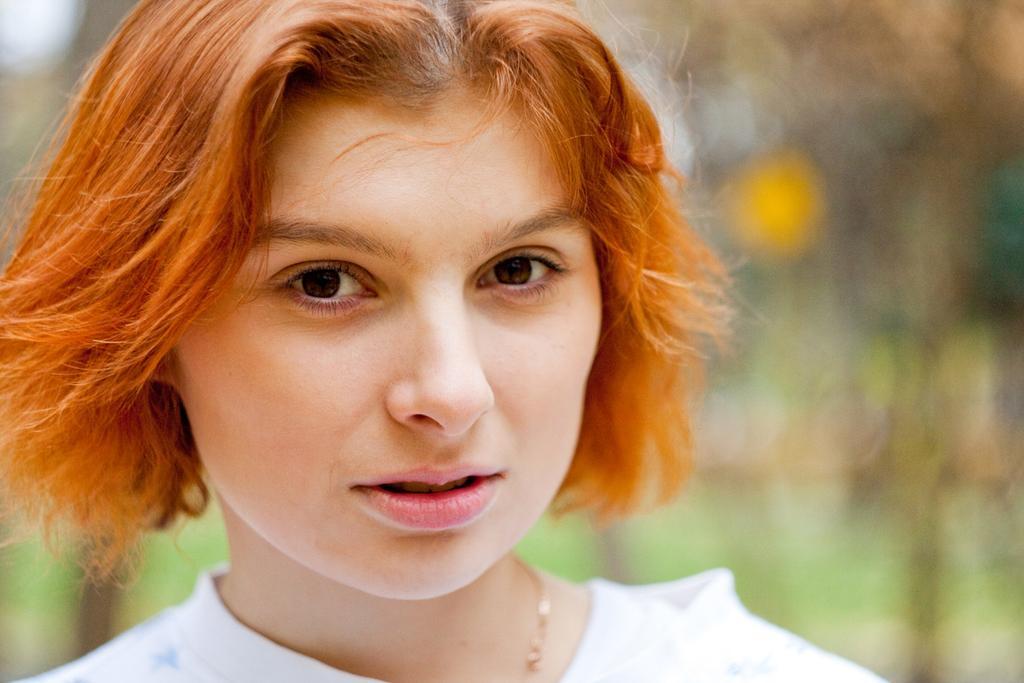How would you summarize this image in a sentence or two? In the center of the image we can see a lady. In the background the image is blur. 